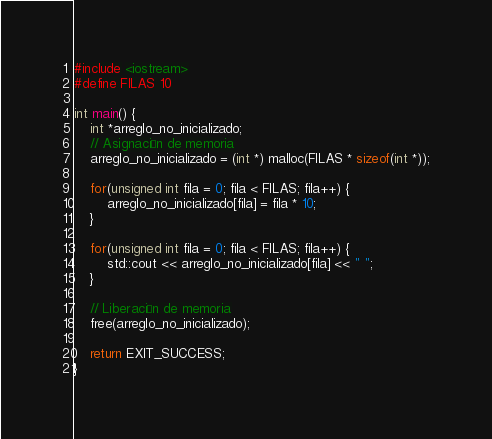Convert code to text. <code><loc_0><loc_0><loc_500><loc_500><_C++_>#include <iostream>
#define FILAS 10

int main() {
    int *arreglo_no_inicializado;
    // Asignación de memoria
    arreglo_no_inicializado = (int *) malloc(FILAS * sizeof(int *));

    for(unsigned int fila = 0; fila < FILAS; fila++) {
        arreglo_no_inicializado[fila] = fila * 10;
    }

    for(unsigned int fila = 0; fila < FILAS; fila++) {
        std::cout << arreglo_no_inicializado[fila] << " ";
    }

    // Liberación de memoria
    free(arreglo_no_inicializado);

    return EXIT_SUCCESS;
}</code> 